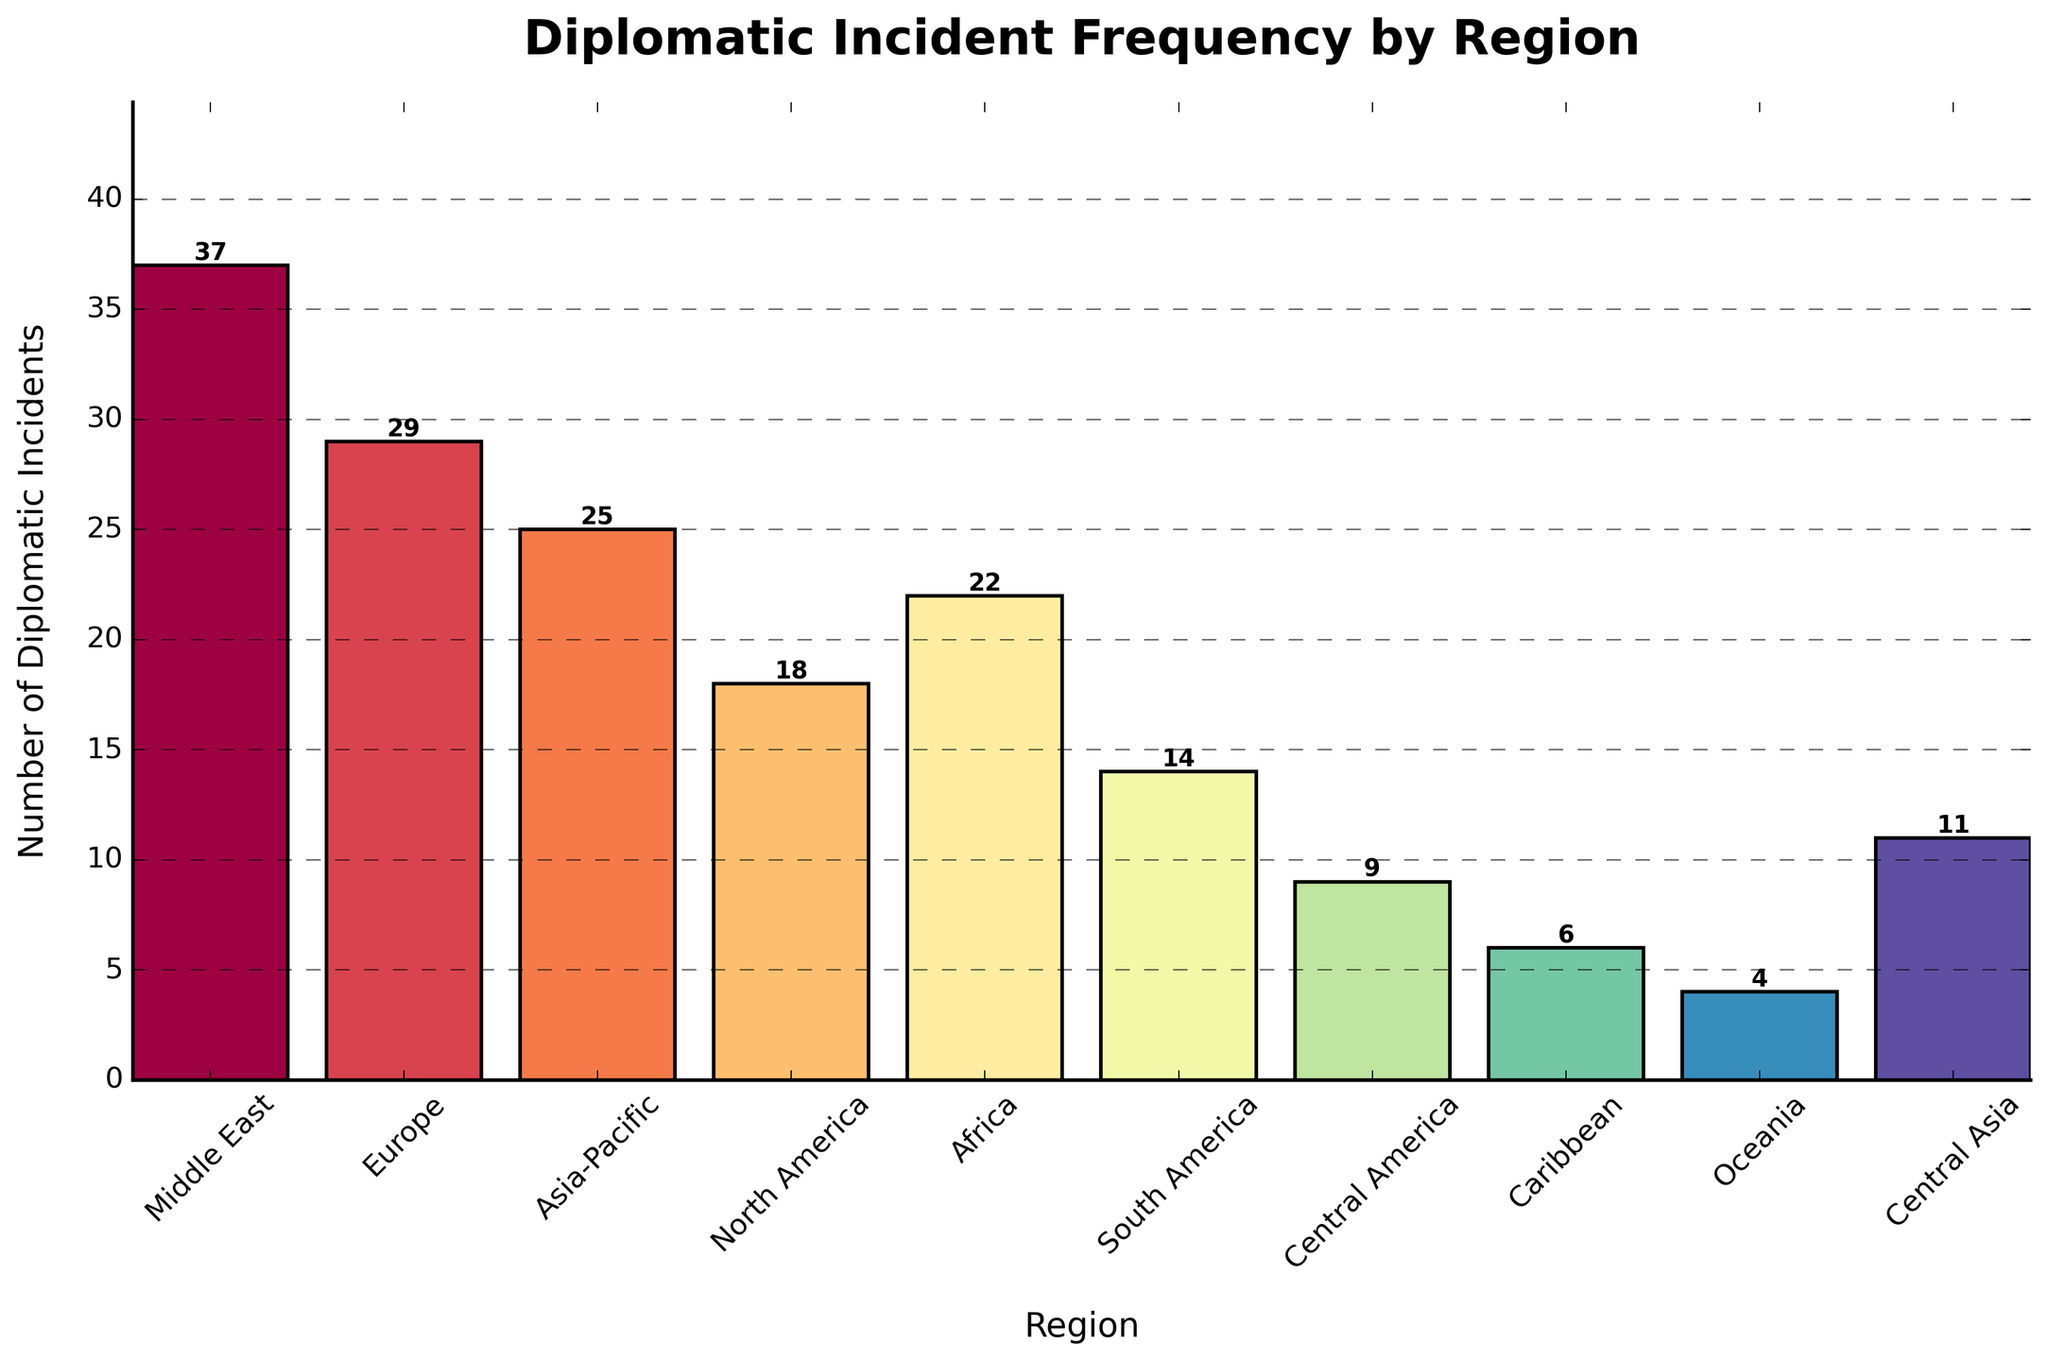Which region has the highest number of diplomatic incidents? The first step is to observe height of bars. The Middle East bar is the tallest. Therefore, it has the highest number of diplomatic incidents.
Answer: Middle East Which region has fewer diplomatic incidents, Caribbean or Oceania? The Caribbean bar is more elevated than Oceania bar but not as much. Thus, Caribbean has fewer diplomatic incidents.
Answer: Caribbean How many more diplomatic incidents does Europe have than North America? First, identify the height of Europe's bar is 29 and North America's bar is 18. Difference between 29 and 18 is 11.
Answer: 11 What is the total number of diplomatic incidents for Africa and South America combined? Africa incidents are 22, South America incidents are 14. Summing them gives 22 + 14 = 36.
Answer: 36 Which region has precisely half the number of diplomatic incidents as Middle East? Middle East has 37 incidents. Half of 37 is 18.5, which rounds to 18. North America's bar represents precisely 18 incidents.
Answer: North America Is the number of diplomatic incidents in Central Asia greater than or equal to that in Central America? Central Asia is 11, Central America is 9. Since 11 is greater than 9, Central Asia has more incidents.
Answer: Central Asia If the average number of diplomatic incidents for all regions is considered, which region is closest to this average? Adding incidents: 37 + 29 + 25 + 18 + 22 + 14 + 9 + 6 + 4 + 11 = 175; average is 175 ÷ 10 = 17.5. North America, with 18 incidents, is closest to the average.
Answer: North America Compare and state if the incidents in Oceania are less than half of Asia-Pacific's incidents. Asia-Pacific has 25 incidents. Half of 25 is 12.5. Oceania has 4 incidents, which is less than 12.5.
Answer: Yes What is the combined total number of diplomatic incidents among the regions with fewer than 20 incidents each? Regions with < 20 incidents: North America (18), South America (14), Central America (9), Caribbean (6), Oceania (4), Central Asia (11). Total: 18 + 14 + 9 + 6 + 4 + 11 = 62.
Answer: 62 